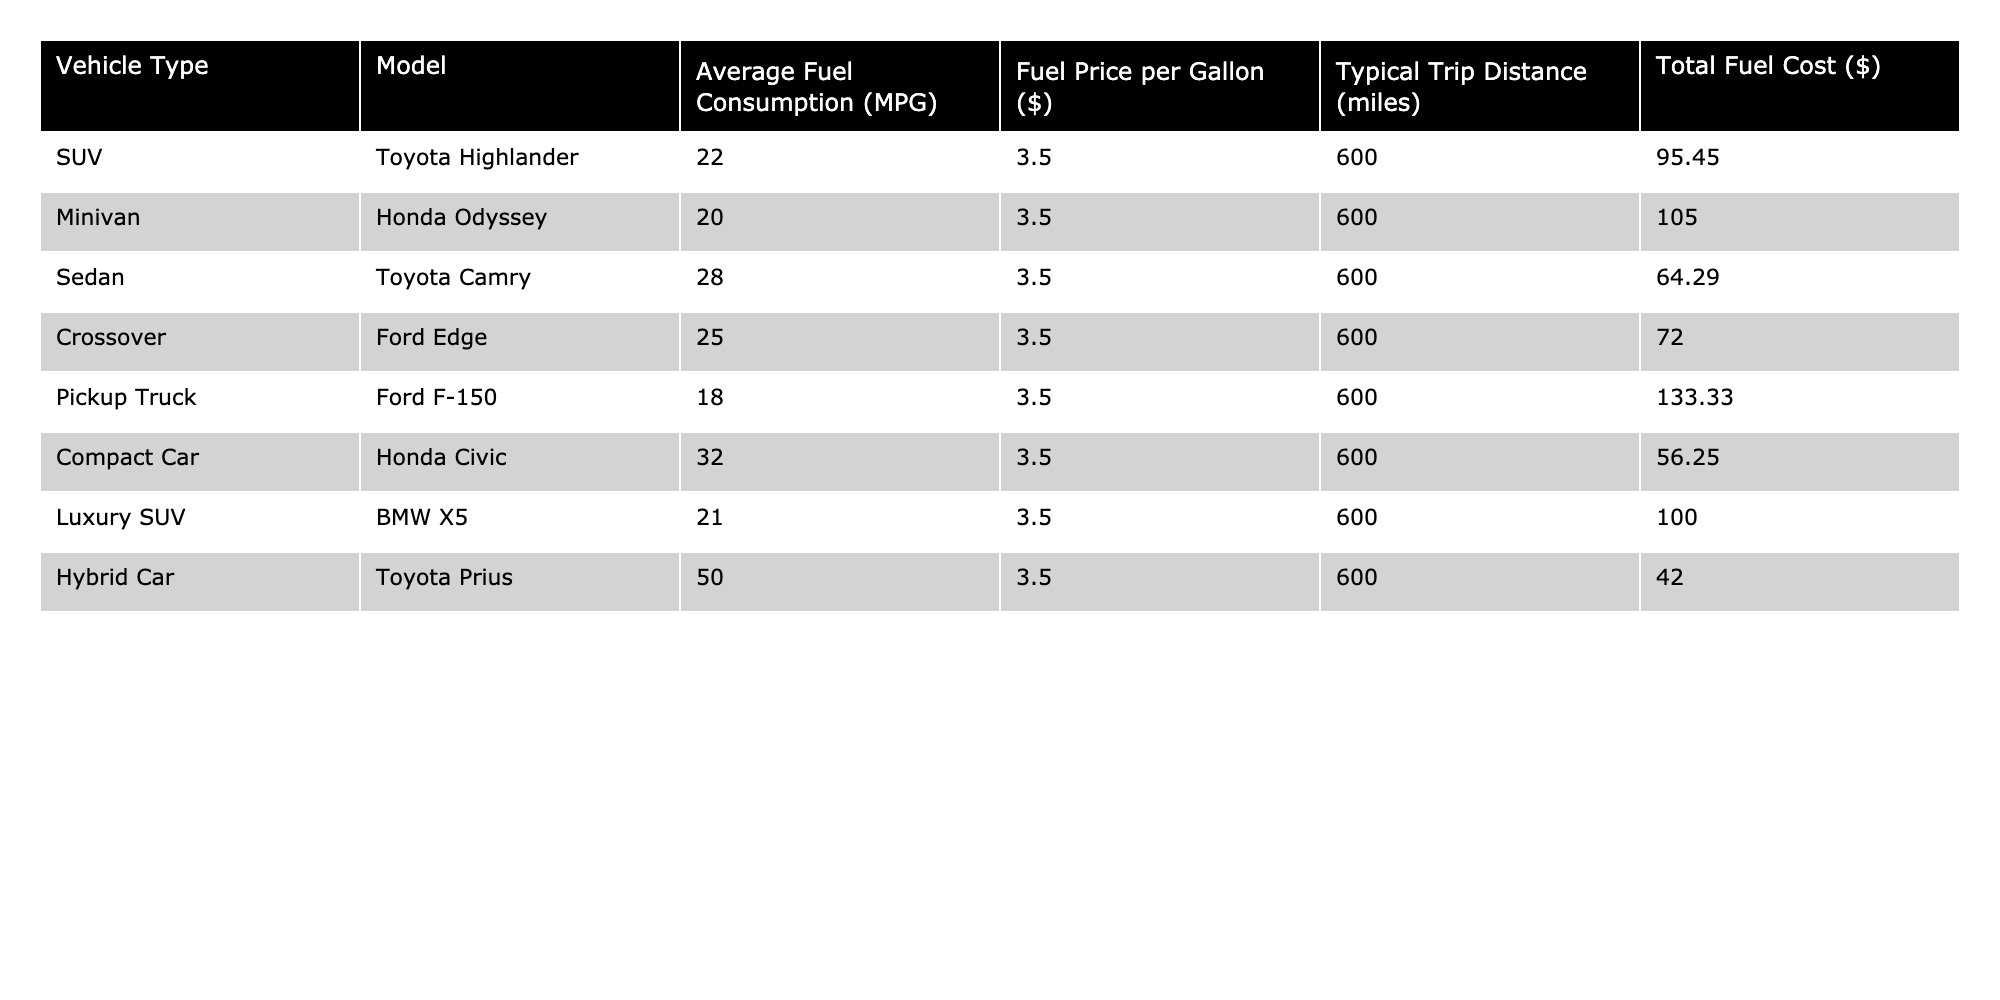What is the average fuel consumption of the vehicles? To find the average fuel consumption, add all the average fuel consumption values (22 + 20 + 28 + 25 + 18 + 32 + 21 + 50 = 216) and divide by the number of vehicles (8). So, 216 / 8 = 27 MPG.
Answer: 27 MPG Which vehicle has the highest total fuel cost for a 600-mile trip? By checking the total fuel cost for each vehicle, the Pickup Truck's cost is 133.33 dollars, which is the highest among all listed vehicles.
Answer: Pickup Truck What is the total fuel cost for all vehicles combined? The total fuel cost is obtained by summing all individual costs: 95.45 + 105.00 + 64.29 + 72.00 + 133.33 + 56.25 + 100.00 + 42.00 = 618.32 dollars.
Answer: 618.32 dollars Is the Honda Odyssey more fuel-efficient than the Ford F-150? The average fuel consumption of the Honda Odyssey is 20 MPG, while the Ford F-150's average is 18 MPG. Since 20 is greater than 18, it indicates the Odyssey is more fuel-efficient than the F-150.
Answer: Yes Which vehicle offers the best fuel efficiency for long trips? The vehicle with the highest average fuel consumption is the Hybrid Car (Toyota Prius) at 50 MPG, which makes it the most fuel-efficient option for long trips.
Answer: Toyota Prius If a family drove the SUV and the Compact Car, how much more would they pay in fuel costs than if they drove the Hybrid Car? The SUV costs 95.45 dollars, the Compact Car costs 56.25 dollars, and the Hybrid Car costs 42.00 dollars. First, find the total cost of the SUV and Compact Car: 95.45 + 56.25 = 151.70 dollars. Then, subtract the Hybrid Car cost: 151.70 - 42.00 = 109.70 dollars.
Answer: 109.70 dollars What is the least expensive vehicle in terms of fuel cost for this trip? Examine the total fuel costs, and the Compact Car has the lowest total cost of 56.25 dollars, making it the least expensive option.
Answer: Compact Car How much does the Luxury SUV cost more in fuel than the Sedan? The Luxury SUV costs 100.00 dollars, and the Sedan costs 64.29 dollars. Subtract the Sedan's cost from the Luxury SUV's cost: 100.00 - 64.29 = 35.71 dollars.
Answer: 35.71 dollars Are there any vehicles that cost less than 70 dollars for fuel on this trip? Checking the fuel costs, the Compact Car (56.25 dollars) and the Hybrid Car (42.00 dollars) both cost less than 70 dollars.
Answer: Yes If the fuel price per gallon increased to $4.00, what would be the new total fuel cost for the Prius? The original fuel cost of the Prius is 42.00 dollars at $3.50 per gallon, then we need to calculate the new cost: First, find the new fuel consumption rate: (50 MPG / 3.50) * 4.00 = 57.14 dollars. Therefore, for a 600-mile trip, the total cost would be: (600 / 50) * 4.00 = 48.00 dollars.
Answer: 48.00 dollars 